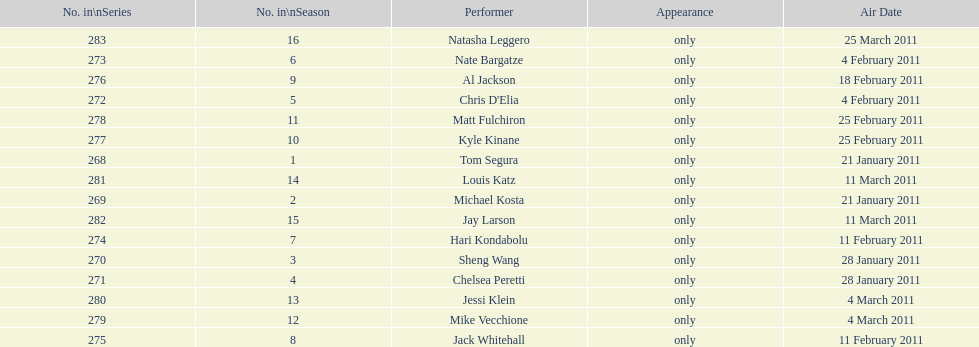How many comedians made their only appearance on comedy central presents in season 15? 16. 